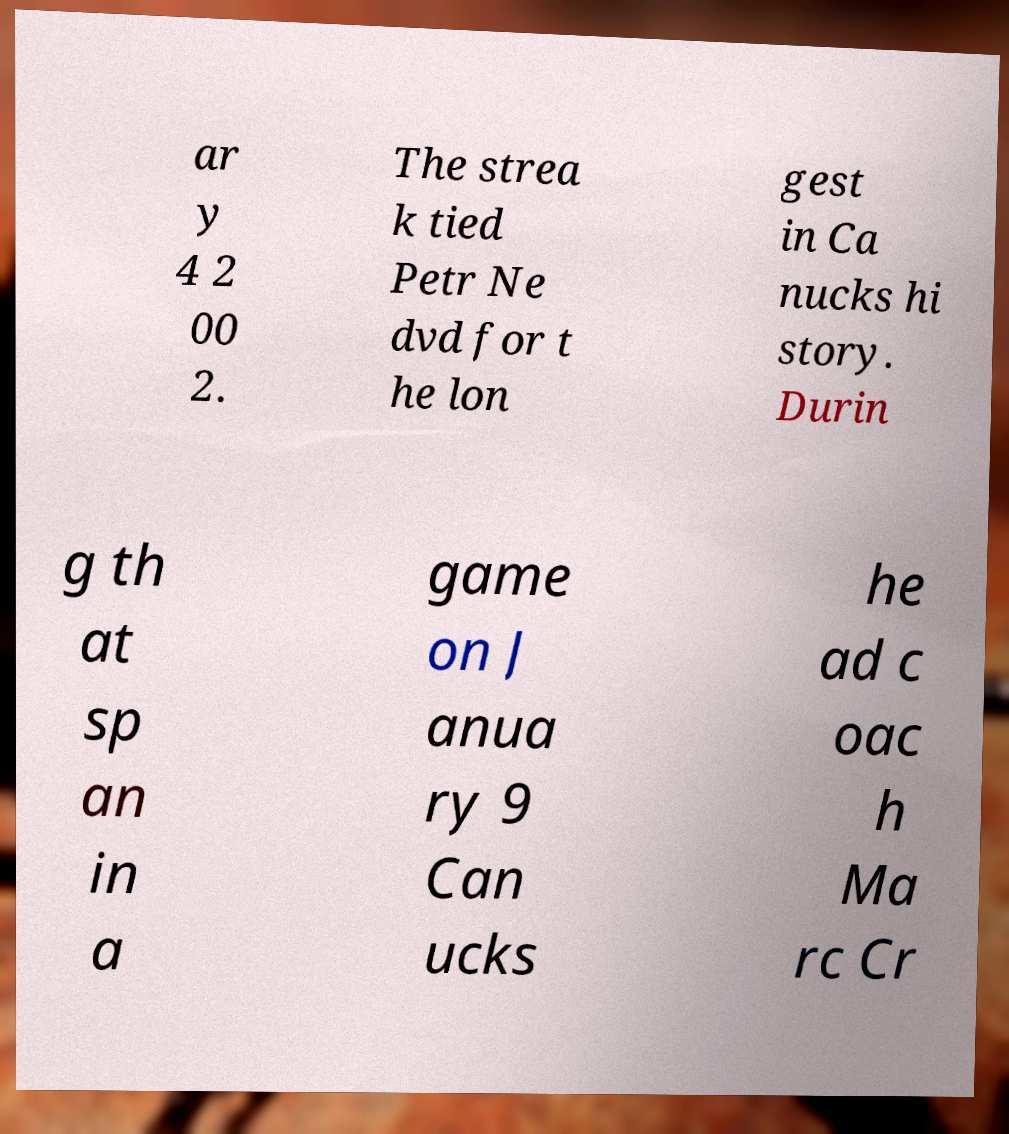There's text embedded in this image that I need extracted. Can you transcribe it verbatim? ar y 4 2 00 2. The strea k tied Petr Ne dvd for t he lon gest in Ca nucks hi story. Durin g th at sp an in a game on J anua ry 9 Can ucks he ad c oac h Ma rc Cr 